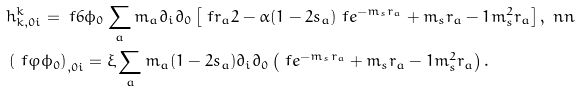<formula> <loc_0><loc_0><loc_500><loc_500>& h ^ { k } _ { k , 0 i } = \ f { 6 } { \phi _ { 0 } } \sum _ { a } m _ { a } \partial _ { i } \partial _ { 0 } \left [ \ f { r _ { a } } { 2 } - \alpha ( 1 - 2 s _ { a } ) \ f { e ^ { - m _ { s } r _ { a } } + m _ { s } r _ { a } - 1 } { m _ { s } ^ { 2 } r _ { a } } \right ] , \ n n \\ & \left ( \ f { \varphi } { \phi _ { 0 } } \right ) _ { , 0 i } = \xi \sum _ { a } m _ { a } ( 1 - 2 s _ { a } ) \partial _ { i } \partial _ { 0 } \left ( \ f { e ^ { - m _ { s } r _ { a } } + m _ { s } r _ { a } - 1 } { m _ { s } ^ { 2 } r _ { a } } \right ) .</formula> 